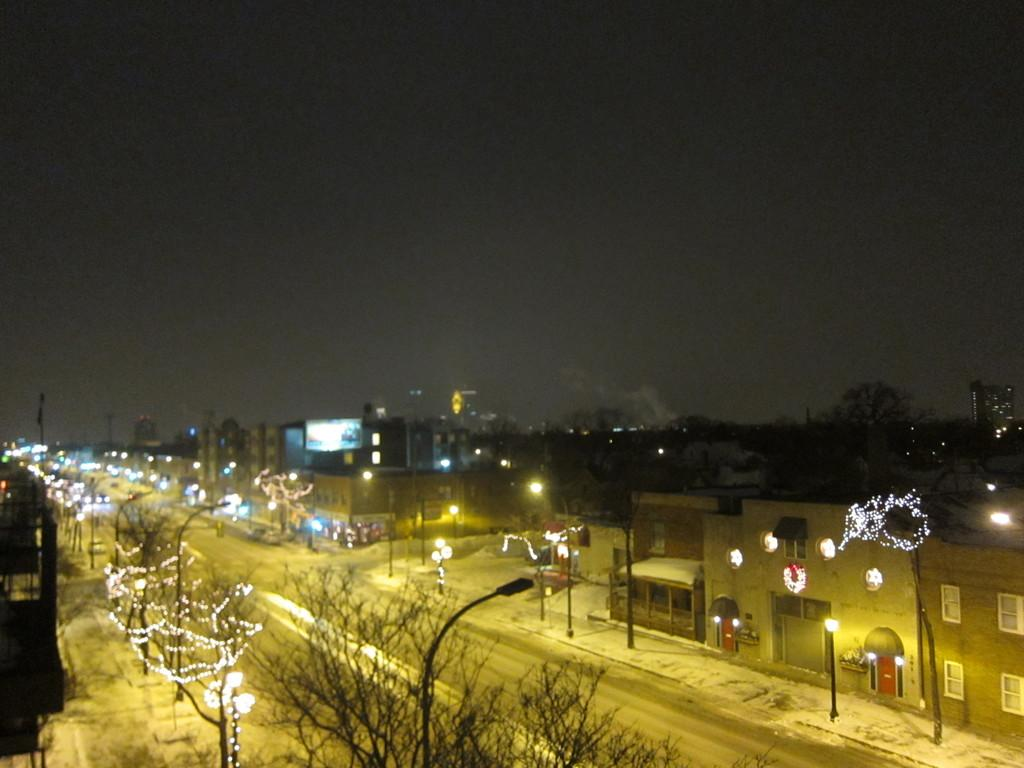What type of natural elements can be seen in the image? There are trees in the image. What type of man-made structures are present in the image? There are buildings in the image. What type of lighting is present in the image? There are pole lights and lights on the trees in the image. What part of the natural environment is visible in the image? The sky is visible in the image. How many vests can be seen hanging on the trees in the image? There are no vests present in the image; it features trees, buildings, pole lights, lights on the trees, and a visible sky. What type of regret can be observed in the image? There is no regret present in the image; it is a visual representation of trees, buildings, pole lights, lights on the trees, and a visible sky. 